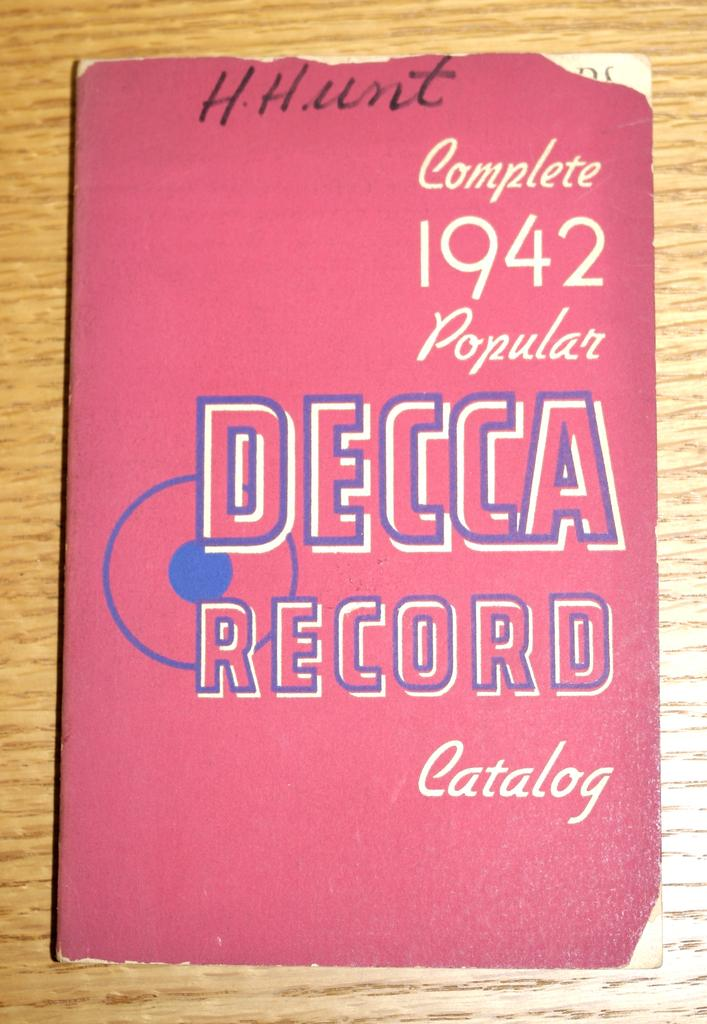<image>
Describe the image concisely. A complete 1942 popular Decca Record Catalog book singed by H.Hunt 